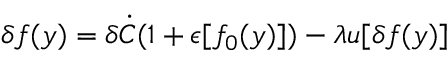Convert formula to latex. <formula><loc_0><loc_0><loc_500><loc_500>\delta f ( y ) = \delta \dot { C } ( 1 + \epsilon [ f _ { 0 } ( y ) ] ) - \lambda u [ \delta f ( y ) ]</formula> 